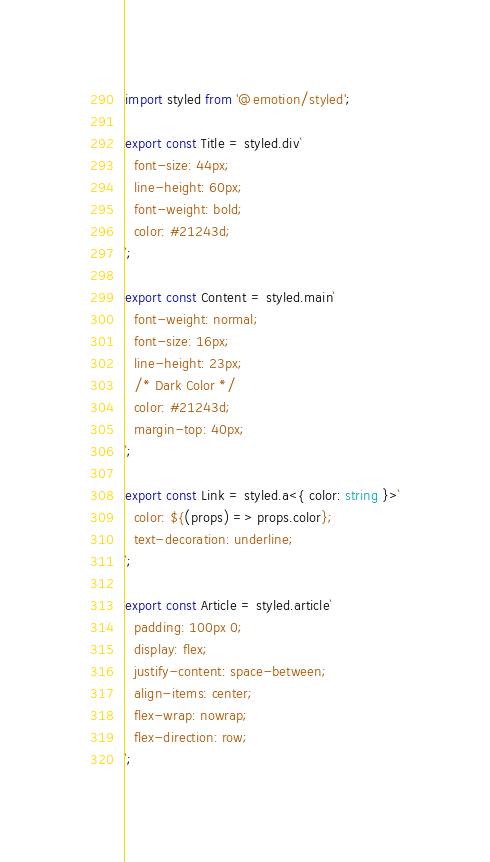Convert code to text. <code><loc_0><loc_0><loc_500><loc_500><_TypeScript_>import styled from '@emotion/styled';

export const Title = styled.div`
  font-size: 44px;
  line-height: 60px;
  font-weight: bold;
  color: #21243d;
`;

export const Content = styled.main`
  font-weight: normal;
  font-size: 16px;
  line-height: 23px;
  /* Dark Color */
  color: #21243d;
  margin-top: 40px;
`;

export const Link = styled.a<{ color: string }>`
  color: ${(props) => props.color};
  text-decoration: underline;
`;

export const Article = styled.article`
  padding: 100px 0;
  display: flex;
  justify-content: space-between;
  align-items: center;
  flex-wrap: nowrap;
  flex-direction: row;
`;
</code> 